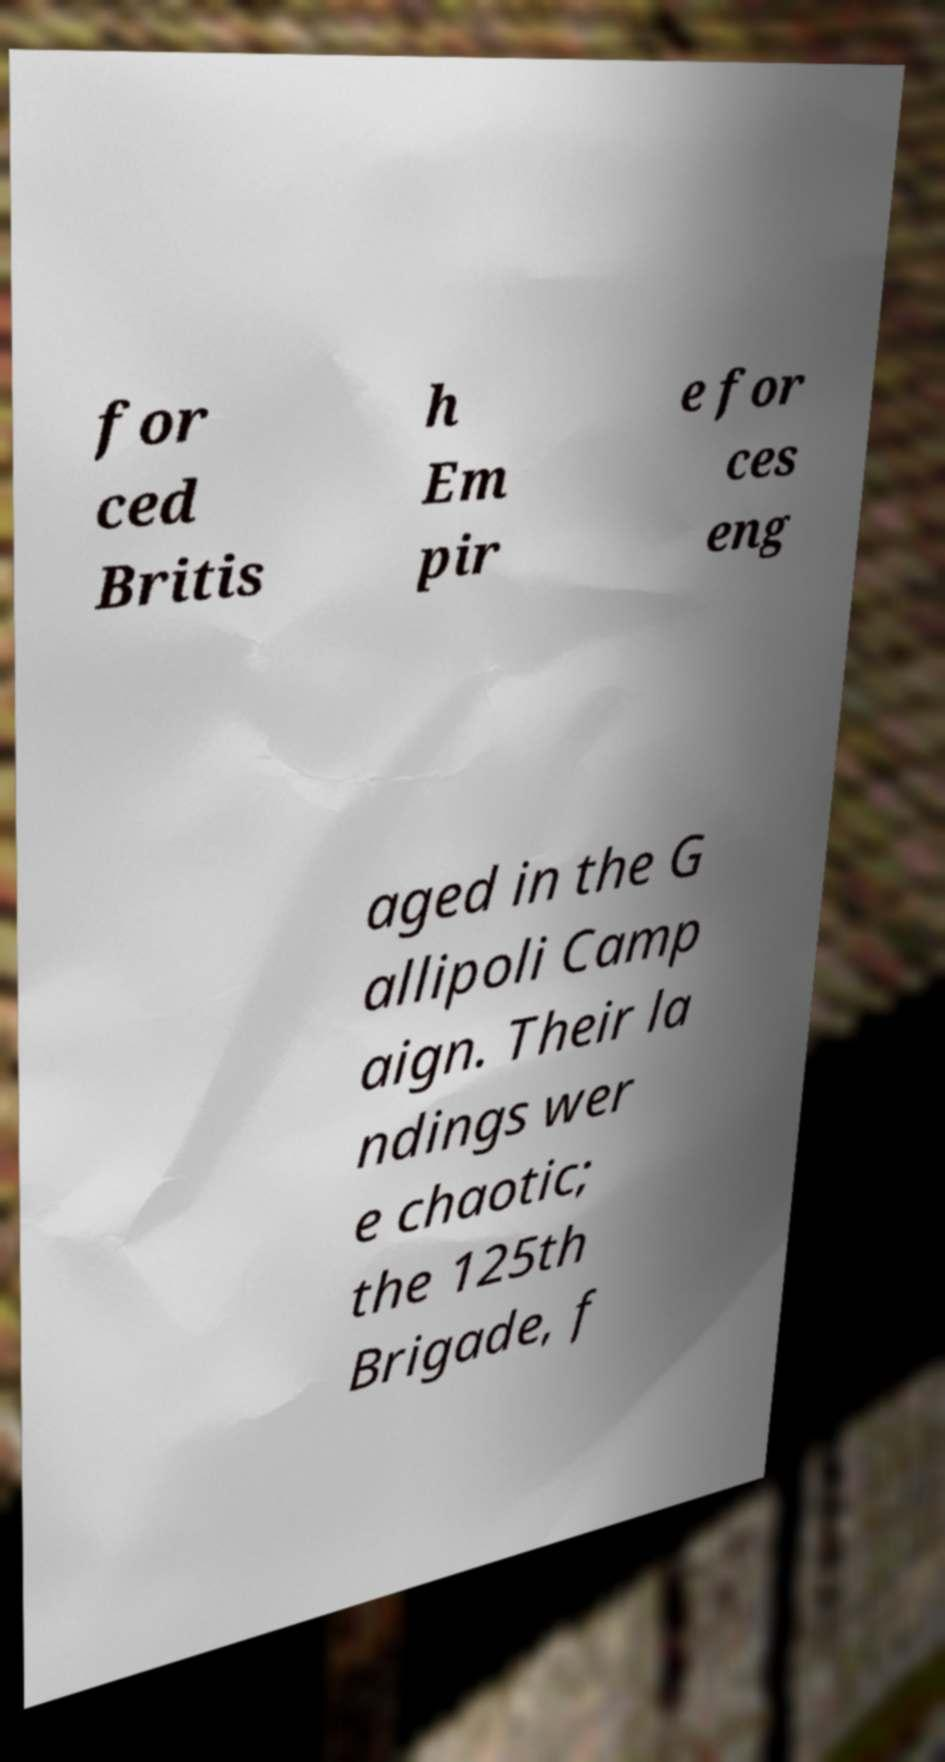What messages or text are displayed in this image? I need them in a readable, typed format. for ced Britis h Em pir e for ces eng aged in the G allipoli Camp aign. Their la ndings wer e chaotic; the 125th Brigade, f 